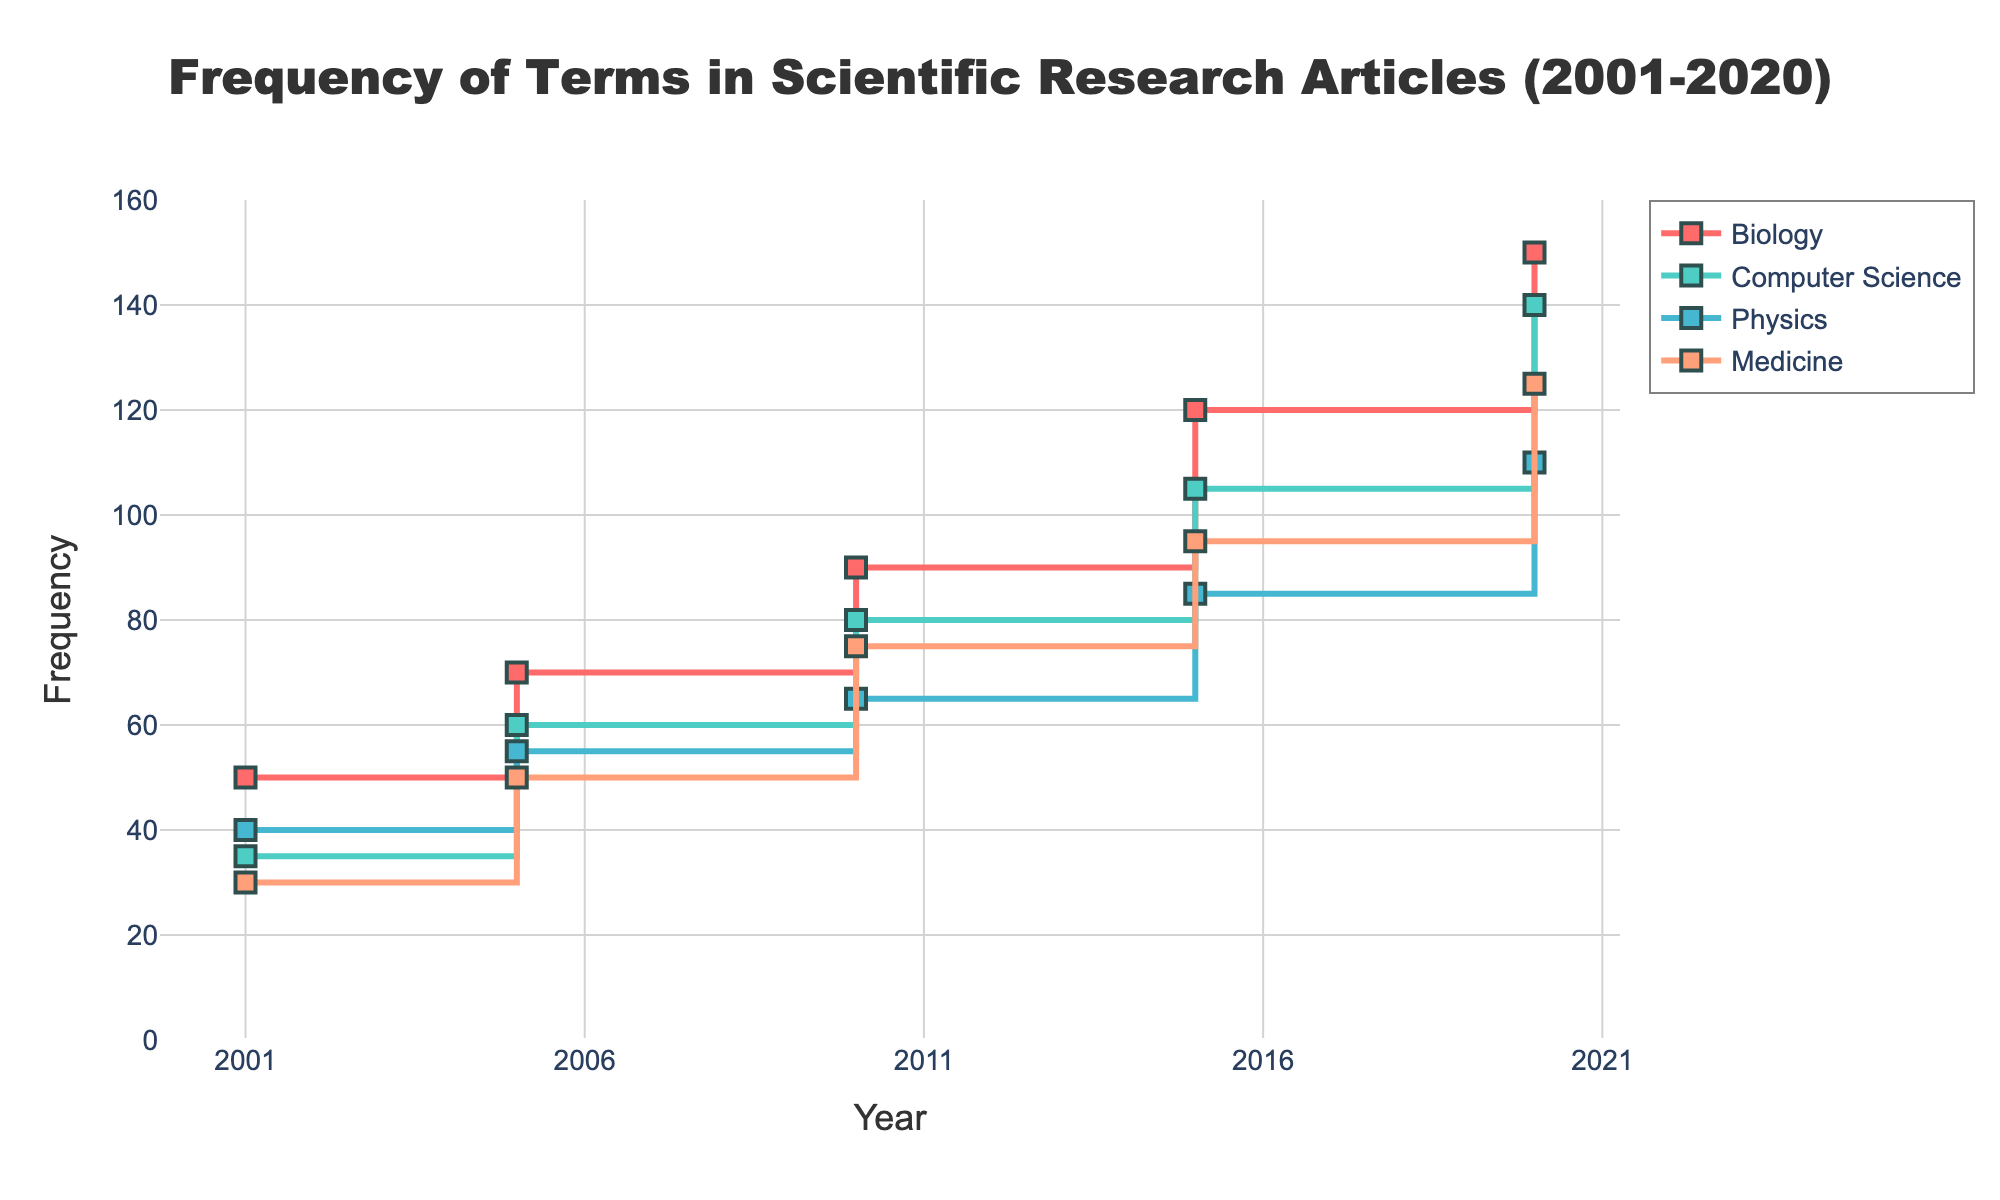What's the title of the plot? The title is at the top center of the plot. It reads "Frequency of Terms in Scientific Research Articles (2001-2020)."
Answer: Frequency of Terms in Scientific Research Articles (2001-2020) What is the frequency of "Genetic mutation" in 2020? Look at the Medicine section for the year 2020. The y-axis value for "Genetic mutation" is 125.
Answer: 125 Which term had the highest frequency in 2020? By comparing all the lines at the year 2020, "Gene expression" in Biology has the highest frequency of 150.
Answer: Gene expression Compare the frequencies of "Machine learning" in 2001 and 2020. By how much did the frequency increase? Check the frequencies of "Machine learning" in Computer Science for the years 2001 and 2020. The values are 35 and 140 respectively. The increase is 140 - 35.
Answer: 105 Which subject domain had the most consistent growth in frequency over the years? Look at the slopes of the lines from 2001 to 2020. The Computer Science line representing "Machine learning" shows consistent growth.
Answer: Computer Science What is the overall trend of "Quantum mechanics" frequency in Physics from 2001 to 2020? Observe the dark-colored line for Physics marking "Quantum mechanics." It starts at 40 in 2001 and increases steadily to 110 in 2020.
Answer: Increasing trend Between 2005 and 2010, in which domain did the term frequency increase the least? Compare the frequency increases between 2005 and 2010 for all domains. Their values are: Biology (20), Computer Science (20), Physics (10), Medicine (25). The smallest increase is in Physics.
Answer: Physics What is the average frequency of "Gene expression" in Biology over all the years shown? The values for "Gene expression" in Biology for the years 2001, 2005, 2010, 2015, and 2020 are 50, 70, 90, 120, and 150 respectively. The average is (50+70+90+120+150)/5.
Answer: 96 In which year did "Genetic mutation" in Medicine experience the highest growth compared to the previous available data point? Calculate the differences between consecutive years for "Genetic mutation" in Medicine: 2001-2005 (20), 2005-2010 (25), 2010-2015 (20), 2015-2020 (30). The highest growth was between 2015 and 2020.
Answer: 2015-2020 Which domain had the highest frequency for a term in 2005, and what was the term and frequency? Check the frequencies in 2005 for all domains. "Gene expression" in Biology has the highest frequency of 70.
Answer: Biology, Gene expression, 70 